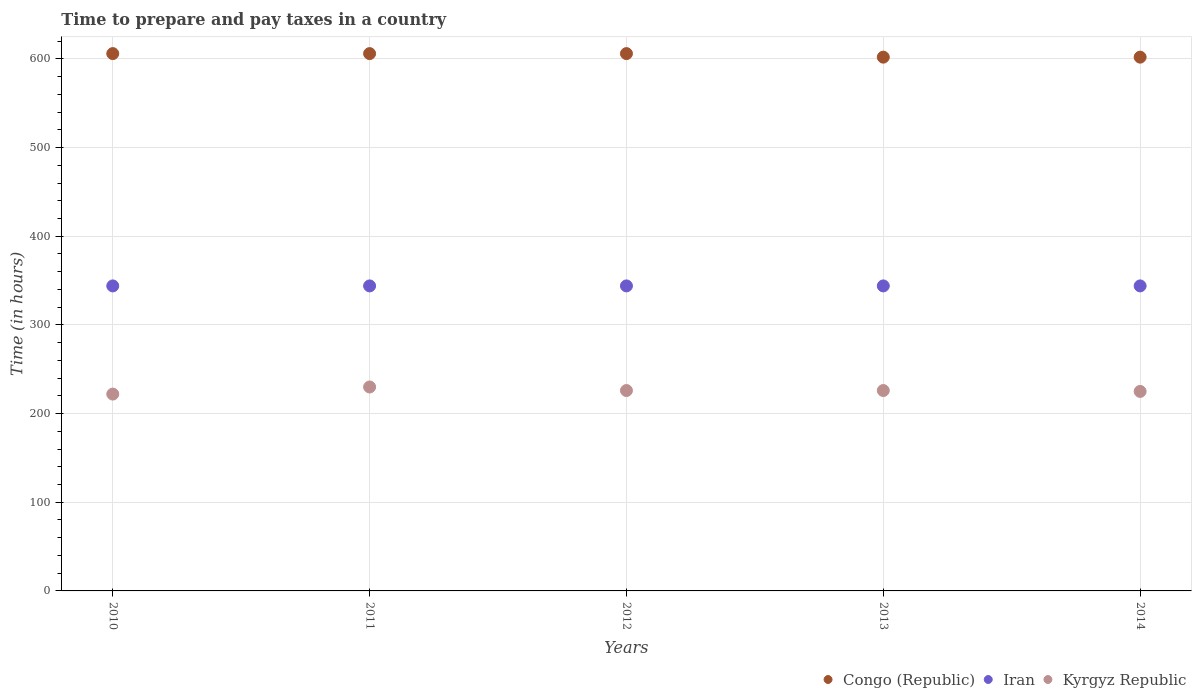Is the number of dotlines equal to the number of legend labels?
Ensure brevity in your answer.  Yes. What is the number of hours required to prepare and pay taxes in Iran in 2014?
Provide a short and direct response. 344. Across all years, what is the maximum number of hours required to prepare and pay taxes in Kyrgyz Republic?
Your response must be concise. 230. Across all years, what is the minimum number of hours required to prepare and pay taxes in Iran?
Your answer should be compact. 344. In which year was the number of hours required to prepare and pay taxes in Kyrgyz Republic minimum?
Ensure brevity in your answer.  2010. What is the total number of hours required to prepare and pay taxes in Congo (Republic) in the graph?
Your response must be concise. 3022. What is the difference between the number of hours required to prepare and pay taxes in Kyrgyz Republic in 2010 and that in 2012?
Your answer should be compact. -4. What is the difference between the number of hours required to prepare and pay taxes in Kyrgyz Republic in 2014 and the number of hours required to prepare and pay taxes in Iran in 2012?
Offer a terse response. -119. What is the average number of hours required to prepare and pay taxes in Iran per year?
Give a very brief answer. 344. In the year 2010, what is the difference between the number of hours required to prepare and pay taxes in Kyrgyz Republic and number of hours required to prepare and pay taxes in Congo (Republic)?
Your answer should be very brief. -384. What is the ratio of the number of hours required to prepare and pay taxes in Kyrgyz Republic in 2011 to that in 2012?
Make the answer very short. 1.02. What is the difference between the highest and the second highest number of hours required to prepare and pay taxes in Iran?
Provide a succinct answer. 0. What is the difference between the highest and the lowest number of hours required to prepare and pay taxes in Kyrgyz Republic?
Offer a terse response. 8. In how many years, is the number of hours required to prepare and pay taxes in Kyrgyz Republic greater than the average number of hours required to prepare and pay taxes in Kyrgyz Republic taken over all years?
Keep it short and to the point. 3. Is it the case that in every year, the sum of the number of hours required to prepare and pay taxes in Kyrgyz Republic and number of hours required to prepare and pay taxes in Congo (Republic)  is greater than the number of hours required to prepare and pay taxes in Iran?
Give a very brief answer. Yes. Does the number of hours required to prepare and pay taxes in Kyrgyz Republic monotonically increase over the years?
Keep it short and to the point. No. Is the number of hours required to prepare and pay taxes in Kyrgyz Republic strictly greater than the number of hours required to prepare and pay taxes in Iran over the years?
Your response must be concise. No. Is the number of hours required to prepare and pay taxes in Iran strictly less than the number of hours required to prepare and pay taxes in Congo (Republic) over the years?
Provide a short and direct response. Yes. How many dotlines are there?
Provide a succinct answer. 3. How many years are there in the graph?
Provide a short and direct response. 5. What is the difference between two consecutive major ticks on the Y-axis?
Your answer should be very brief. 100. Are the values on the major ticks of Y-axis written in scientific E-notation?
Ensure brevity in your answer.  No. Does the graph contain any zero values?
Your answer should be compact. No. Does the graph contain grids?
Your answer should be very brief. Yes. What is the title of the graph?
Offer a terse response. Time to prepare and pay taxes in a country. What is the label or title of the Y-axis?
Make the answer very short. Time (in hours). What is the Time (in hours) in Congo (Republic) in 2010?
Keep it short and to the point. 606. What is the Time (in hours) of Iran in 2010?
Provide a short and direct response. 344. What is the Time (in hours) of Kyrgyz Republic in 2010?
Offer a terse response. 222. What is the Time (in hours) in Congo (Republic) in 2011?
Offer a very short reply. 606. What is the Time (in hours) of Iran in 2011?
Offer a terse response. 344. What is the Time (in hours) of Kyrgyz Republic in 2011?
Keep it short and to the point. 230. What is the Time (in hours) of Congo (Republic) in 2012?
Provide a succinct answer. 606. What is the Time (in hours) in Iran in 2012?
Ensure brevity in your answer.  344. What is the Time (in hours) of Kyrgyz Republic in 2012?
Keep it short and to the point. 226. What is the Time (in hours) of Congo (Republic) in 2013?
Your response must be concise. 602. What is the Time (in hours) of Iran in 2013?
Provide a short and direct response. 344. What is the Time (in hours) in Kyrgyz Republic in 2013?
Make the answer very short. 226. What is the Time (in hours) in Congo (Republic) in 2014?
Provide a short and direct response. 602. What is the Time (in hours) of Iran in 2014?
Give a very brief answer. 344. What is the Time (in hours) of Kyrgyz Republic in 2014?
Keep it short and to the point. 225. Across all years, what is the maximum Time (in hours) in Congo (Republic)?
Offer a very short reply. 606. Across all years, what is the maximum Time (in hours) in Iran?
Make the answer very short. 344. Across all years, what is the maximum Time (in hours) in Kyrgyz Republic?
Your answer should be very brief. 230. Across all years, what is the minimum Time (in hours) of Congo (Republic)?
Ensure brevity in your answer.  602. Across all years, what is the minimum Time (in hours) in Iran?
Give a very brief answer. 344. Across all years, what is the minimum Time (in hours) in Kyrgyz Republic?
Offer a very short reply. 222. What is the total Time (in hours) in Congo (Republic) in the graph?
Your answer should be compact. 3022. What is the total Time (in hours) of Iran in the graph?
Ensure brevity in your answer.  1720. What is the total Time (in hours) in Kyrgyz Republic in the graph?
Give a very brief answer. 1129. What is the difference between the Time (in hours) in Congo (Republic) in 2010 and that in 2011?
Your answer should be very brief. 0. What is the difference between the Time (in hours) in Iran in 2010 and that in 2011?
Give a very brief answer. 0. What is the difference between the Time (in hours) in Kyrgyz Republic in 2010 and that in 2011?
Give a very brief answer. -8. What is the difference between the Time (in hours) in Congo (Republic) in 2010 and that in 2013?
Ensure brevity in your answer.  4. What is the difference between the Time (in hours) of Iran in 2010 and that in 2013?
Ensure brevity in your answer.  0. What is the difference between the Time (in hours) of Congo (Republic) in 2010 and that in 2014?
Provide a succinct answer. 4. What is the difference between the Time (in hours) of Iran in 2010 and that in 2014?
Provide a short and direct response. 0. What is the difference between the Time (in hours) of Kyrgyz Republic in 2010 and that in 2014?
Your answer should be very brief. -3. What is the difference between the Time (in hours) in Congo (Republic) in 2011 and that in 2012?
Your response must be concise. 0. What is the difference between the Time (in hours) in Iran in 2011 and that in 2012?
Your answer should be compact. 0. What is the difference between the Time (in hours) of Kyrgyz Republic in 2011 and that in 2012?
Give a very brief answer. 4. What is the difference between the Time (in hours) in Iran in 2011 and that in 2013?
Make the answer very short. 0. What is the difference between the Time (in hours) in Congo (Republic) in 2011 and that in 2014?
Your answer should be compact. 4. What is the difference between the Time (in hours) in Congo (Republic) in 2012 and that in 2013?
Ensure brevity in your answer.  4. What is the difference between the Time (in hours) in Iran in 2012 and that in 2014?
Provide a short and direct response. 0. What is the difference between the Time (in hours) of Kyrgyz Republic in 2012 and that in 2014?
Your answer should be very brief. 1. What is the difference between the Time (in hours) of Congo (Republic) in 2013 and that in 2014?
Your response must be concise. 0. What is the difference between the Time (in hours) of Congo (Republic) in 2010 and the Time (in hours) of Iran in 2011?
Your response must be concise. 262. What is the difference between the Time (in hours) of Congo (Republic) in 2010 and the Time (in hours) of Kyrgyz Republic in 2011?
Provide a succinct answer. 376. What is the difference between the Time (in hours) of Iran in 2010 and the Time (in hours) of Kyrgyz Republic in 2011?
Provide a short and direct response. 114. What is the difference between the Time (in hours) in Congo (Republic) in 2010 and the Time (in hours) in Iran in 2012?
Offer a very short reply. 262. What is the difference between the Time (in hours) of Congo (Republic) in 2010 and the Time (in hours) of Kyrgyz Republic in 2012?
Keep it short and to the point. 380. What is the difference between the Time (in hours) of Iran in 2010 and the Time (in hours) of Kyrgyz Republic in 2012?
Your response must be concise. 118. What is the difference between the Time (in hours) of Congo (Republic) in 2010 and the Time (in hours) of Iran in 2013?
Offer a terse response. 262. What is the difference between the Time (in hours) in Congo (Republic) in 2010 and the Time (in hours) in Kyrgyz Republic in 2013?
Your response must be concise. 380. What is the difference between the Time (in hours) in Iran in 2010 and the Time (in hours) in Kyrgyz Republic in 2013?
Keep it short and to the point. 118. What is the difference between the Time (in hours) of Congo (Republic) in 2010 and the Time (in hours) of Iran in 2014?
Offer a very short reply. 262. What is the difference between the Time (in hours) of Congo (Republic) in 2010 and the Time (in hours) of Kyrgyz Republic in 2014?
Your answer should be very brief. 381. What is the difference between the Time (in hours) in Iran in 2010 and the Time (in hours) in Kyrgyz Republic in 2014?
Keep it short and to the point. 119. What is the difference between the Time (in hours) in Congo (Republic) in 2011 and the Time (in hours) in Iran in 2012?
Ensure brevity in your answer.  262. What is the difference between the Time (in hours) in Congo (Republic) in 2011 and the Time (in hours) in Kyrgyz Republic in 2012?
Make the answer very short. 380. What is the difference between the Time (in hours) in Iran in 2011 and the Time (in hours) in Kyrgyz Republic in 2012?
Your answer should be very brief. 118. What is the difference between the Time (in hours) in Congo (Republic) in 2011 and the Time (in hours) in Iran in 2013?
Give a very brief answer. 262. What is the difference between the Time (in hours) of Congo (Republic) in 2011 and the Time (in hours) of Kyrgyz Republic in 2013?
Your answer should be compact. 380. What is the difference between the Time (in hours) in Iran in 2011 and the Time (in hours) in Kyrgyz Republic in 2013?
Your response must be concise. 118. What is the difference between the Time (in hours) in Congo (Republic) in 2011 and the Time (in hours) in Iran in 2014?
Your answer should be very brief. 262. What is the difference between the Time (in hours) of Congo (Republic) in 2011 and the Time (in hours) of Kyrgyz Republic in 2014?
Your response must be concise. 381. What is the difference between the Time (in hours) in Iran in 2011 and the Time (in hours) in Kyrgyz Republic in 2014?
Offer a very short reply. 119. What is the difference between the Time (in hours) in Congo (Republic) in 2012 and the Time (in hours) in Iran in 2013?
Provide a succinct answer. 262. What is the difference between the Time (in hours) in Congo (Republic) in 2012 and the Time (in hours) in Kyrgyz Republic in 2013?
Ensure brevity in your answer.  380. What is the difference between the Time (in hours) of Iran in 2012 and the Time (in hours) of Kyrgyz Republic in 2013?
Offer a terse response. 118. What is the difference between the Time (in hours) of Congo (Republic) in 2012 and the Time (in hours) of Iran in 2014?
Your answer should be compact. 262. What is the difference between the Time (in hours) of Congo (Republic) in 2012 and the Time (in hours) of Kyrgyz Republic in 2014?
Offer a terse response. 381. What is the difference between the Time (in hours) of Iran in 2012 and the Time (in hours) of Kyrgyz Republic in 2014?
Your answer should be compact. 119. What is the difference between the Time (in hours) of Congo (Republic) in 2013 and the Time (in hours) of Iran in 2014?
Provide a short and direct response. 258. What is the difference between the Time (in hours) in Congo (Republic) in 2013 and the Time (in hours) in Kyrgyz Republic in 2014?
Offer a terse response. 377. What is the difference between the Time (in hours) in Iran in 2013 and the Time (in hours) in Kyrgyz Republic in 2014?
Give a very brief answer. 119. What is the average Time (in hours) of Congo (Republic) per year?
Offer a terse response. 604.4. What is the average Time (in hours) in Iran per year?
Give a very brief answer. 344. What is the average Time (in hours) in Kyrgyz Republic per year?
Offer a terse response. 225.8. In the year 2010, what is the difference between the Time (in hours) of Congo (Republic) and Time (in hours) of Iran?
Your answer should be very brief. 262. In the year 2010, what is the difference between the Time (in hours) in Congo (Republic) and Time (in hours) in Kyrgyz Republic?
Your answer should be very brief. 384. In the year 2010, what is the difference between the Time (in hours) of Iran and Time (in hours) of Kyrgyz Republic?
Offer a very short reply. 122. In the year 2011, what is the difference between the Time (in hours) of Congo (Republic) and Time (in hours) of Iran?
Your response must be concise. 262. In the year 2011, what is the difference between the Time (in hours) in Congo (Republic) and Time (in hours) in Kyrgyz Republic?
Provide a succinct answer. 376. In the year 2011, what is the difference between the Time (in hours) of Iran and Time (in hours) of Kyrgyz Republic?
Offer a terse response. 114. In the year 2012, what is the difference between the Time (in hours) of Congo (Republic) and Time (in hours) of Iran?
Provide a short and direct response. 262. In the year 2012, what is the difference between the Time (in hours) of Congo (Republic) and Time (in hours) of Kyrgyz Republic?
Provide a succinct answer. 380. In the year 2012, what is the difference between the Time (in hours) of Iran and Time (in hours) of Kyrgyz Republic?
Ensure brevity in your answer.  118. In the year 2013, what is the difference between the Time (in hours) of Congo (Republic) and Time (in hours) of Iran?
Keep it short and to the point. 258. In the year 2013, what is the difference between the Time (in hours) of Congo (Republic) and Time (in hours) of Kyrgyz Republic?
Offer a terse response. 376. In the year 2013, what is the difference between the Time (in hours) of Iran and Time (in hours) of Kyrgyz Republic?
Your answer should be compact. 118. In the year 2014, what is the difference between the Time (in hours) in Congo (Republic) and Time (in hours) in Iran?
Your response must be concise. 258. In the year 2014, what is the difference between the Time (in hours) of Congo (Republic) and Time (in hours) of Kyrgyz Republic?
Make the answer very short. 377. In the year 2014, what is the difference between the Time (in hours) of Iran and Time (in hours) of Kyrgyz Republic?
Ensure brevity in your answer.  119. What is the ratio of the Time (in hours) of Congo (Republic) in 2010 to that in 2011?
Ensure brevity in your answer.  1. What is the ratio of the Time (in hours) in Kyrgyz Republic in 2010 to that in 2011?
Your answer should be very brief. 0.97. What is the ratio of the Time (in hours) of Congo (Republic) in 2010 to that in 2012?
Make the answer very short. 1. What is the ratio of the Time (in hours) of Kyrgyz Republic in 2010 to that in 2012?
Make the answer very short. 0.98. What is the ratio of the Time (in hours) of Congo (Republic) in 2010 to that in 2013?
Your answer should be compact. 1.01. What is the ratio of the Time (in hours) in Kyrgyz Republic in 2010 to that in 2013?
Offer a terse response. 0.98. What is the ratio of the Time (in hours) in Congo (Republic) in 2010 to that in 2014?
Keep it short and to the point. 1.01. What is the ratio of the Time (in hours) of Iran in 2010 to that in 2014?
Offer a terse response. 1. What is the ratio of the Time (in hours) in Kyrgyz Republic in 2010 to that in 2014?
Provide a succinct answer. 0.99. What is the ratio of the Time (in hours) in Iran in 2011 to that in 2012?
Make the answer very short. 1. What is the ratio of the Time (in hours) in Kyrgyz Republic in 2011 to that in 2012?
Your response must be concise. 1.02. What is the ratio of the Time (in hours) in Congo (Republic) in 2011 to that in 2013?
Ensure brevity in your answer.  1.01. What is the ratio of the Time (in hours) of Iran in 2011 to that in 2013?
Make the answer very short. 1. What is the ratio of the Time (in hours) of Kyrgyz Republic in 2011 to that in 2013?
Your response must be concise. 1.02. What is the ratio of the Time (in hours) in Congo (Republic) in 2011 to that in 2014?
Your answer should be compact. 1.01. What is the ratio of the Time (in hours) of Iran in 2011 to that in 2014?
Keep it short and to the point. 1. What is the ratio of the Time (in hours) of Kyrgyz Republic in 2011 to that in 2014?
Offer a terse response. 1.02. What is the ratio of the Time (in hours) in Congo (Republic) in 2012 to that in 2013?
Offer a terse response. 1.01. What is the ratio of the Time (in hours) of Kyrgyz Republic in 2012 to that in 2013?
Offer a terse response. 1. What is the ratio of the Time (in hours) in Congo (Republic) in 2012 to that in 2014?
Provide a short and direct response. 1.01. What is the ratio of the Time (in hours) of Kyrgyz Republic in 2012 to that in 2014?
Keep it short and to the point. 1. What is the ratio of the Time (in hours) in Congo (Republic) in 2013 to that in 2014?
Offer a terse response. 1. What is the ratio of the Time (in hours) in Iran in 2013 to that in 2014?
Your response must be concise. 1. What is the difference between the highest and the second highest Time (in hours) in Congo (Republic)?
Your answer should be compact. 0. What is the difference between the highest and the second highest Time (in hours) of Iran?
Make the answer very short. 0. What is the difference between the highest and the second highest Time (in hours) in Kyrgyz Republic?
Ensure brevity in your answer.  4. 